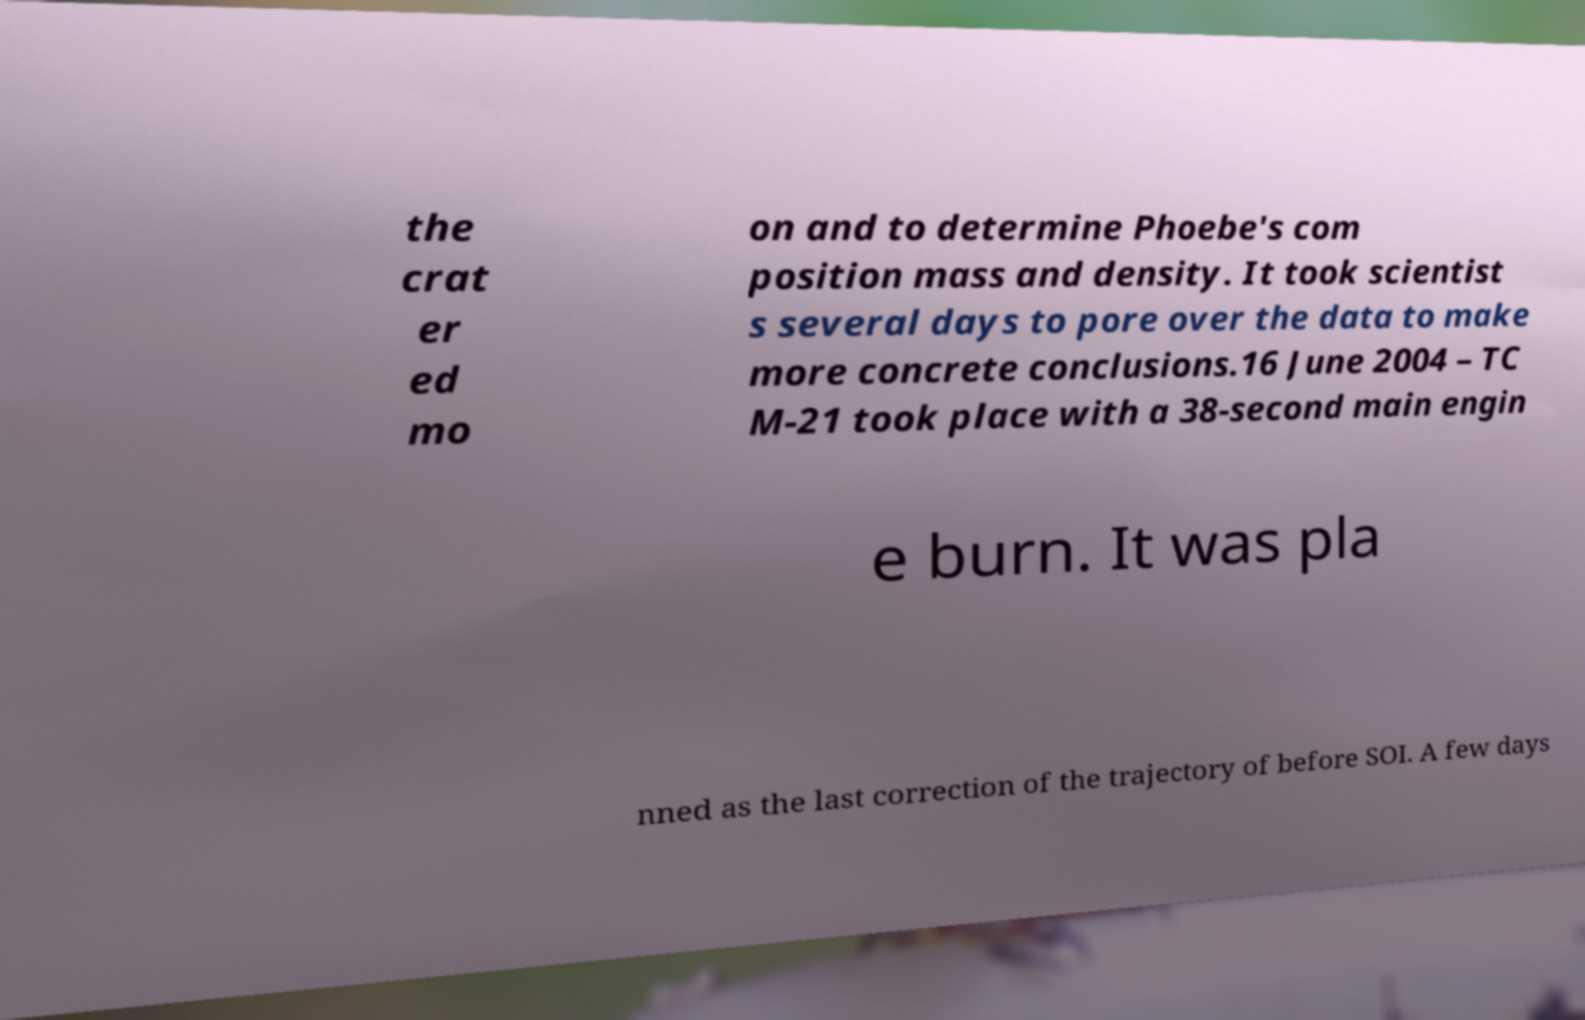Please identify and transcribe the text found in this image. the crat er ed mo on and to determine Phoebe's com position mass and density. It took scientist s several days to pore over the data to make more concrete conclusions.16 June 2004 – TC M-21 took place with a 38-second main engin e burn. It was pla nned as the last correction of the trajectory of before SOI. A few days 